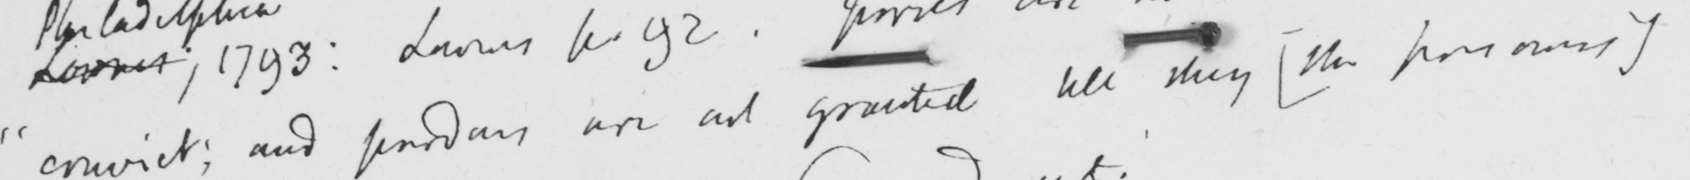Transcribe the text shown in this historical manuscript line. " convict ; and pardons are not granted till they  [ the prisoners ] 